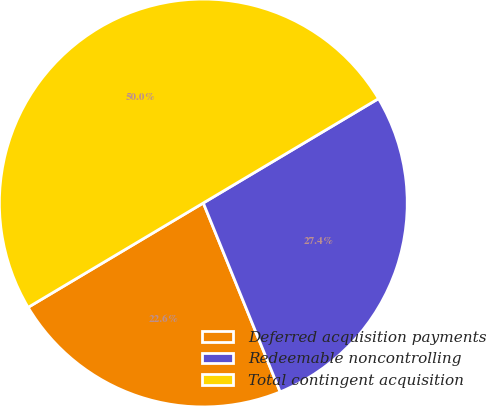Convert chart to OTSL. <chart><loc_0><loc_0><loc_500><loc_500><pie_chart><fcel>Deferred acquisition payments<fcel>Redeemable noncontrolling<fcel>Total contingent acquisition<nl><fcel>22.6%<fcel>27.4%<fcel>50.0%<nl></chart> 